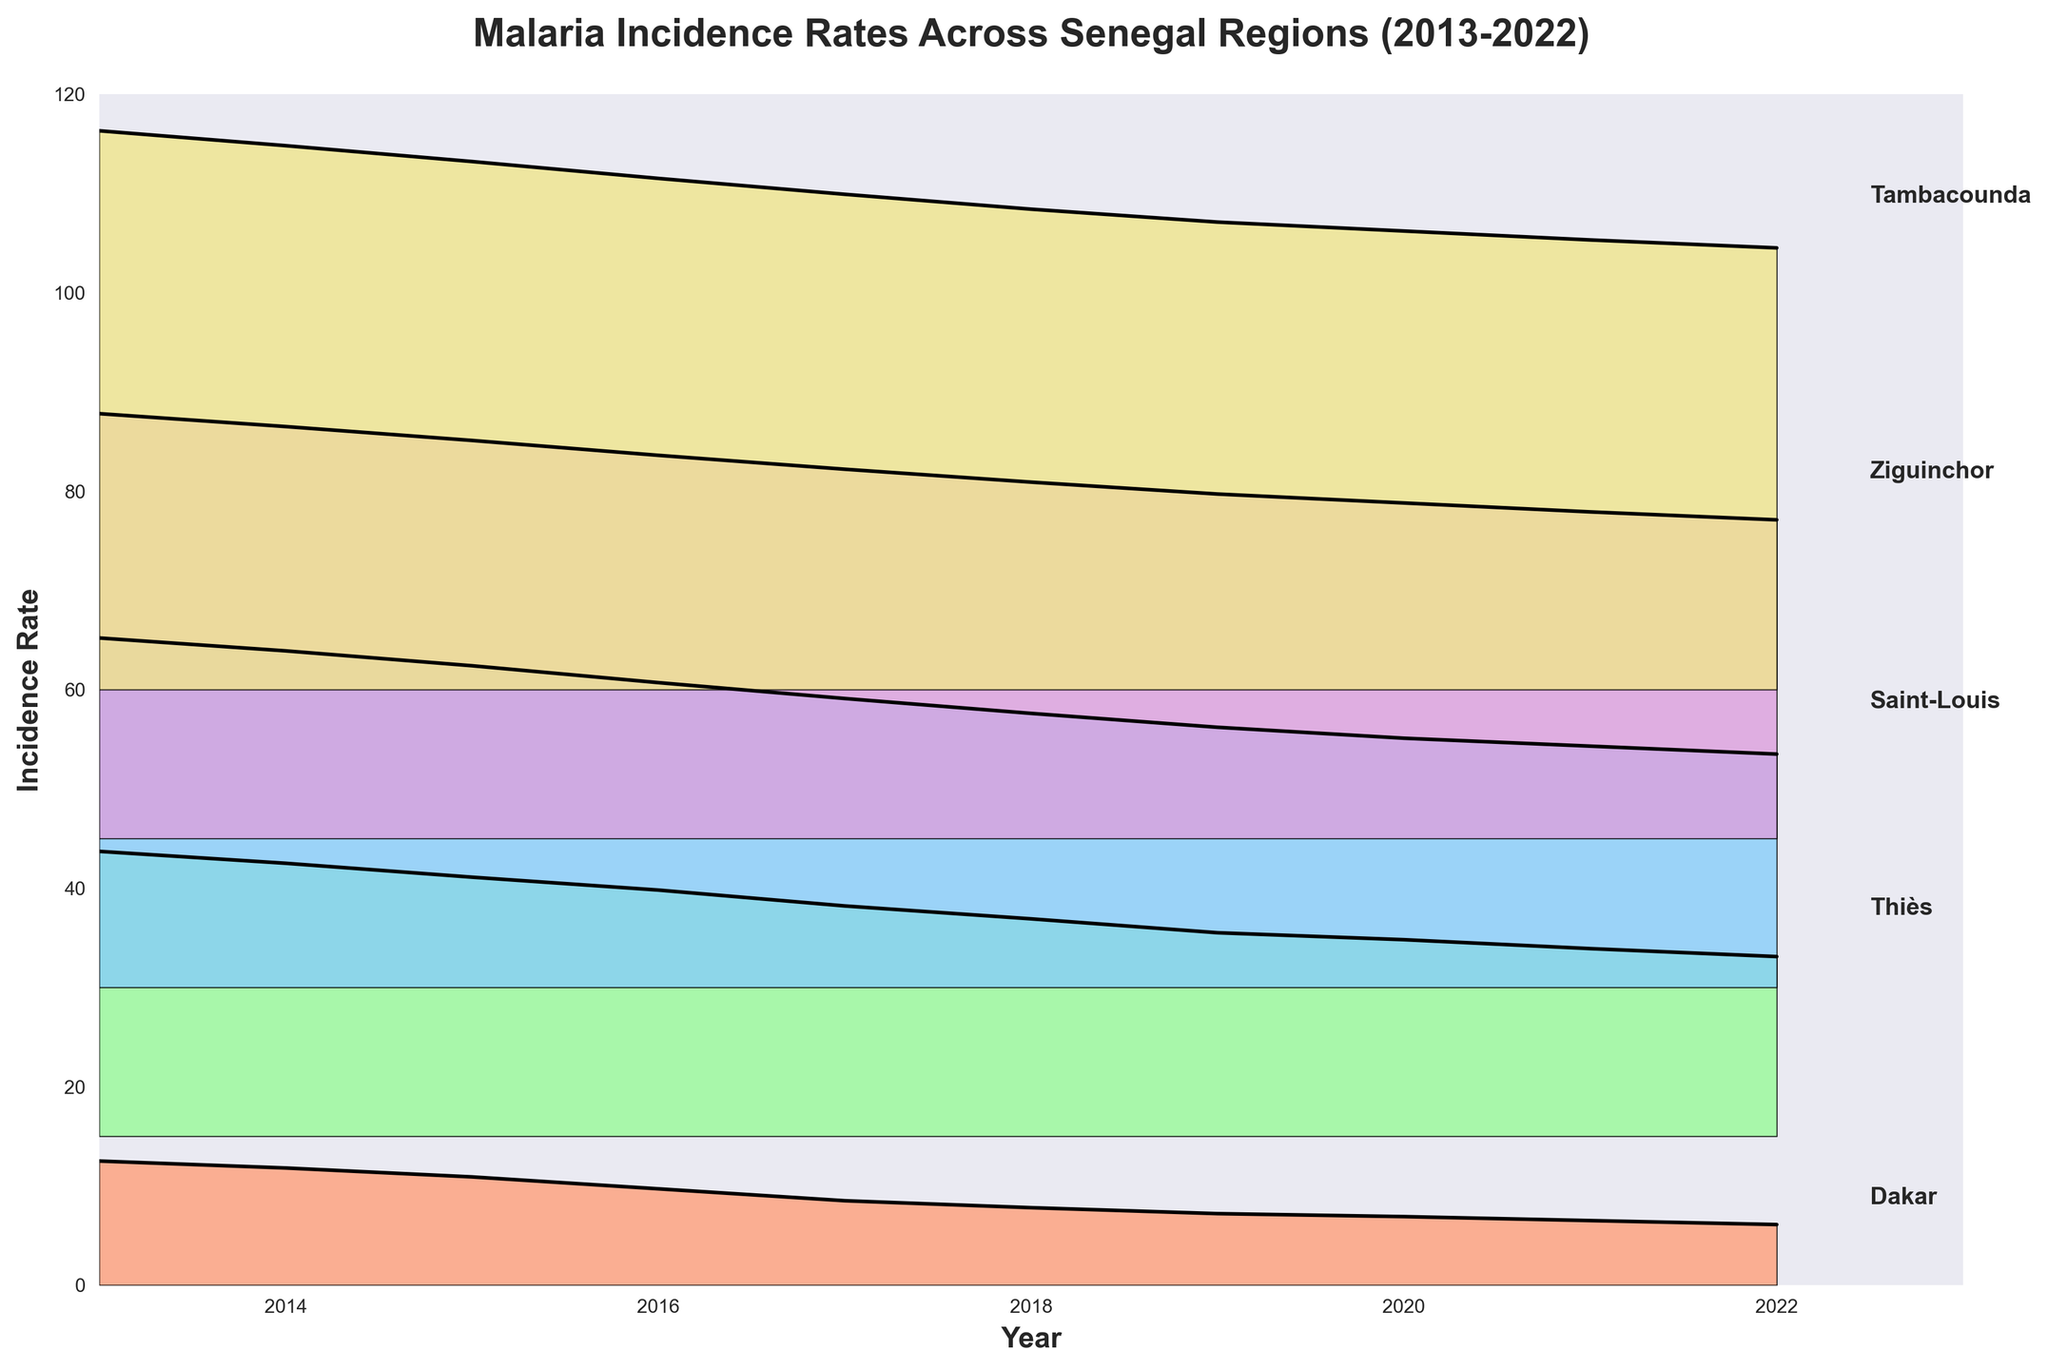what is the overall trend of malaria incidence rates in Dakar from 2013 to 2022? The plot shows the incidence rates for Dakar from 2013 to 2022, starting at around 12.5 and consistently declining each year to reach approximately 6.1 in 2022. This indicates a continuous downward trend in malaria incidence rates in Dakar over the decade.
Answer: Continuous downward trend Which region had the highest malaria incidence rate in 2013? By looking at the height of the ridgelines for 2013, Tambacounda has the highest peak, indicating it had the highest malaria incidence rate.
Answer: Tambacounda Compare the malaria incidence rates of Thiès and Saint-Louis in 2020. Which region had a higher rate? For 2020, you need to look at the heights of the ridgelines marked for the respective regions. Saint-Louis has a slightly higher ridgeline peak compared to Thiès for 2020, indicating a higher incidence rate.
Answer: Saint-Louis What is the average malaria incidence rate for Saint-Louis from 2013 to 2022? The values for Saint-Louis from 2013 to 2022 need to be summed up and then divided by the number of years: (35.2 + 33.9 + 32.4 + 30.7 + 29.1 + 27.6 + 26.2 + 25.1 + 24.3 + 23.5) / 10 = 28.8
Answer: 28.8 How has the incidence rate of malaria in Ziguinchor changed between 2015 and 2020? The incidence rates in Ziguinchor for 2015 and 2020 are examined, showing a decrease from 40.1 in 2015 to 33.8 in 2020, indicating a reduction.
Answer: Decreased Are there any regions where the incidence rate of malaria has remained stable over the years? Inspecting the ridgelines for all regions shows that all regions display a general downward trend in the incidence rates, thus none of the regions have stable rates.
Answer: No Which region has the lowest malaria incidence rate in 2022? By observing the heights of the ridgelines for 2022, Dakar shows the lowest peak when compared to other regions, meaning Dakar has the lowest incidence rate.
Answer: Dakar Calculate the difference in malaria incidence rates between the highest and lowest regions in 2022. The highest incidence rate in 2022 is in Tambacounda (44.5), and the lowest is in Dakar (6.1). The difference is 44.5 - 6.1 = 38.4.
Answer: 38.4 What is the overall trend observed across all regions in the plot? From visual inspection, all regions show a decrease in malaria incidence rates from 2013 to 2022. This indicates a general trend of declining malaria incidence across Senegal.
Answer: Declining trend In what year did Saint-Louis have an incidence rate just above 30? Reviewing the ridgeline for Saint-Louis, it shows an incidence rate above 30 in 2016, but below 35.
Answer: 2016 